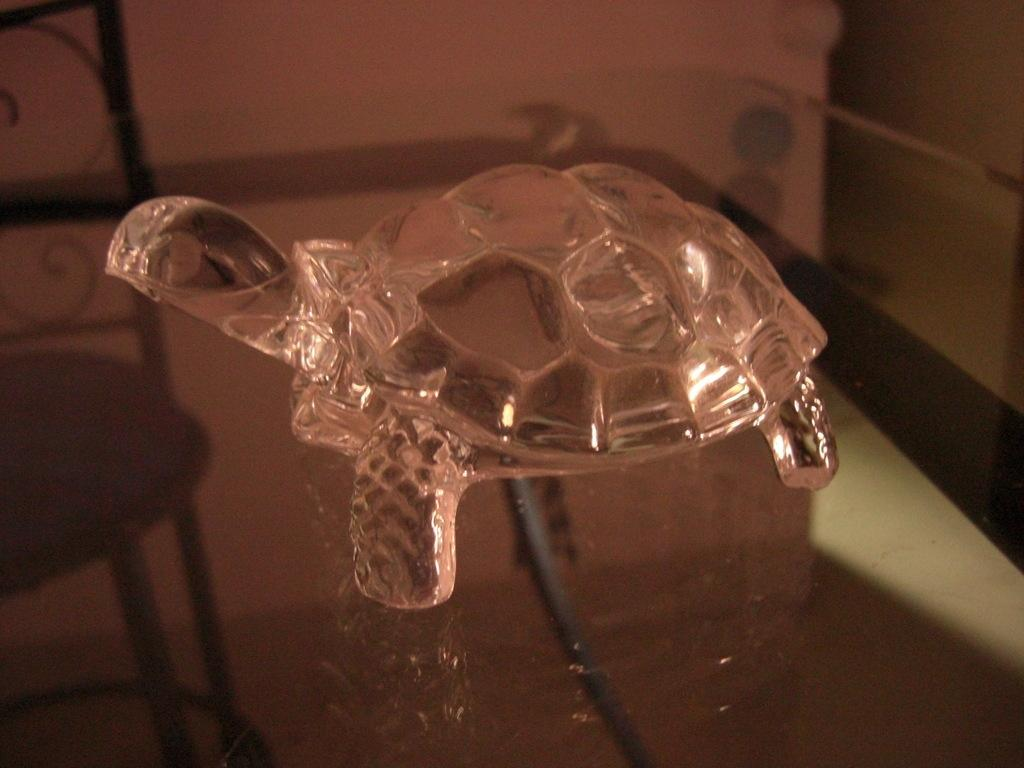What is the main subject of the image? The main subject of the image is a model of a tortoise. Where is the tortoise model located in the image? The model of the tortoise is in the center of the image. On what surface is the tortoise model placed? The tortoise model is on a table. Can you see any caves in the image? There are no caves present in the image; it features a model of a tortoise on a table. What type of sock is the tortoise wearing in the image? The tortoise model in the image is not wearing any socks, as it is a model and not a living creature. 